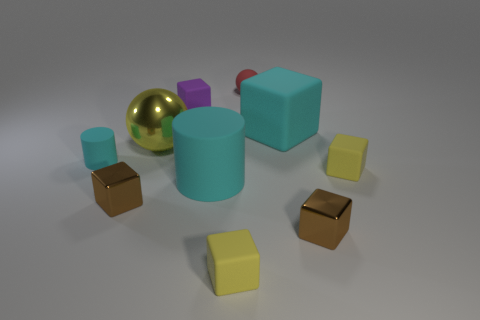There is a tiny purple block; are there any big spheres in front of it?
Offer a terse response. Yes. The tiny thing that is to the left of the large shiny thing and in front of the tiny rubber cylinder is made of what material?
Your response must be concise. Metal. Is the sphere on the left side of the tiny red matte thing made of the same material as the red object?
Provide a succinct answer. No. What material is the big yellow thing?
Your response must be concise. Metal. There is a brown block that is right of the red sphere; what size is it?
Keep it short and to the point. Small. Is there any other thing that is the same color as the big metal sphere?
Offer a very short reply. Yes. There is a brown cube right of the small yellow object that is left of the small red object; are there any cyan rubber objects that are to the right of it?
Ensure brevity in your answer.  No. There is a ball that is behind the large block; does it have the same color as the large ball?
Give a very brief answer. No. How many balls are either cyan objects or large purple rubber things?
Provide a short and direct response. 0. The cyan thing that is behind the big yellow shiny sphere that is in front of the large cyan matte block is what shape?
Your answer should be very brief. Cube. 